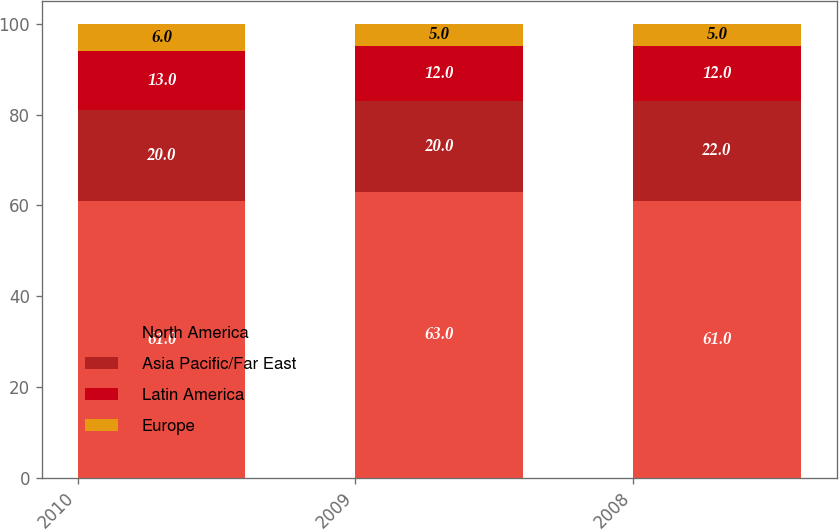<chart> <loc_0><loc_0><loc_500><loc_500><stacked_bar_chart><ecel><fcel>2010<fcel>2009<fcel>2008<nl><fcel>North America<fcel>61<fcel>63<fcel>61<nl><fcel>Asia Pacific/Far East<fcel>20<fcel>20<fcel>22<nl><fcel>Latin America<fcel>13<fcel>12<fcel>12<nl><fcel>Europe<fcel>6<fcel>5<fcel>5<nl></chart> 